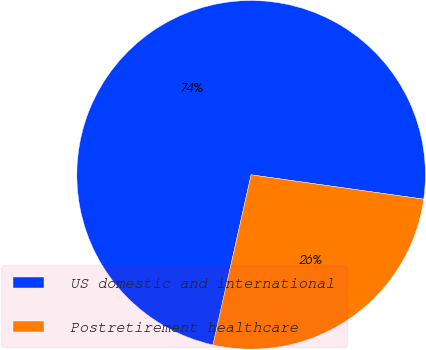Convert chart to OTSL. <chart><loc_0><loc_0><loc_500><loc_500><pie_chart><fcel>US domestic and international<fcel>Postretirement healthcare<nl><fcel>73.72%<fcel>26.28%<nl></chart> 